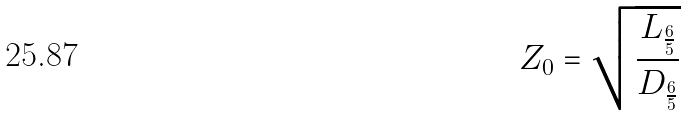<formula> <loc_0><loc_0><loc_500><loc_500>Z _ { 0 } = \sqrt { \frac { L _ { \frac { 6 } { 5 } } } { D _ { \frac { 6 } { 5 } } } }</formula> 